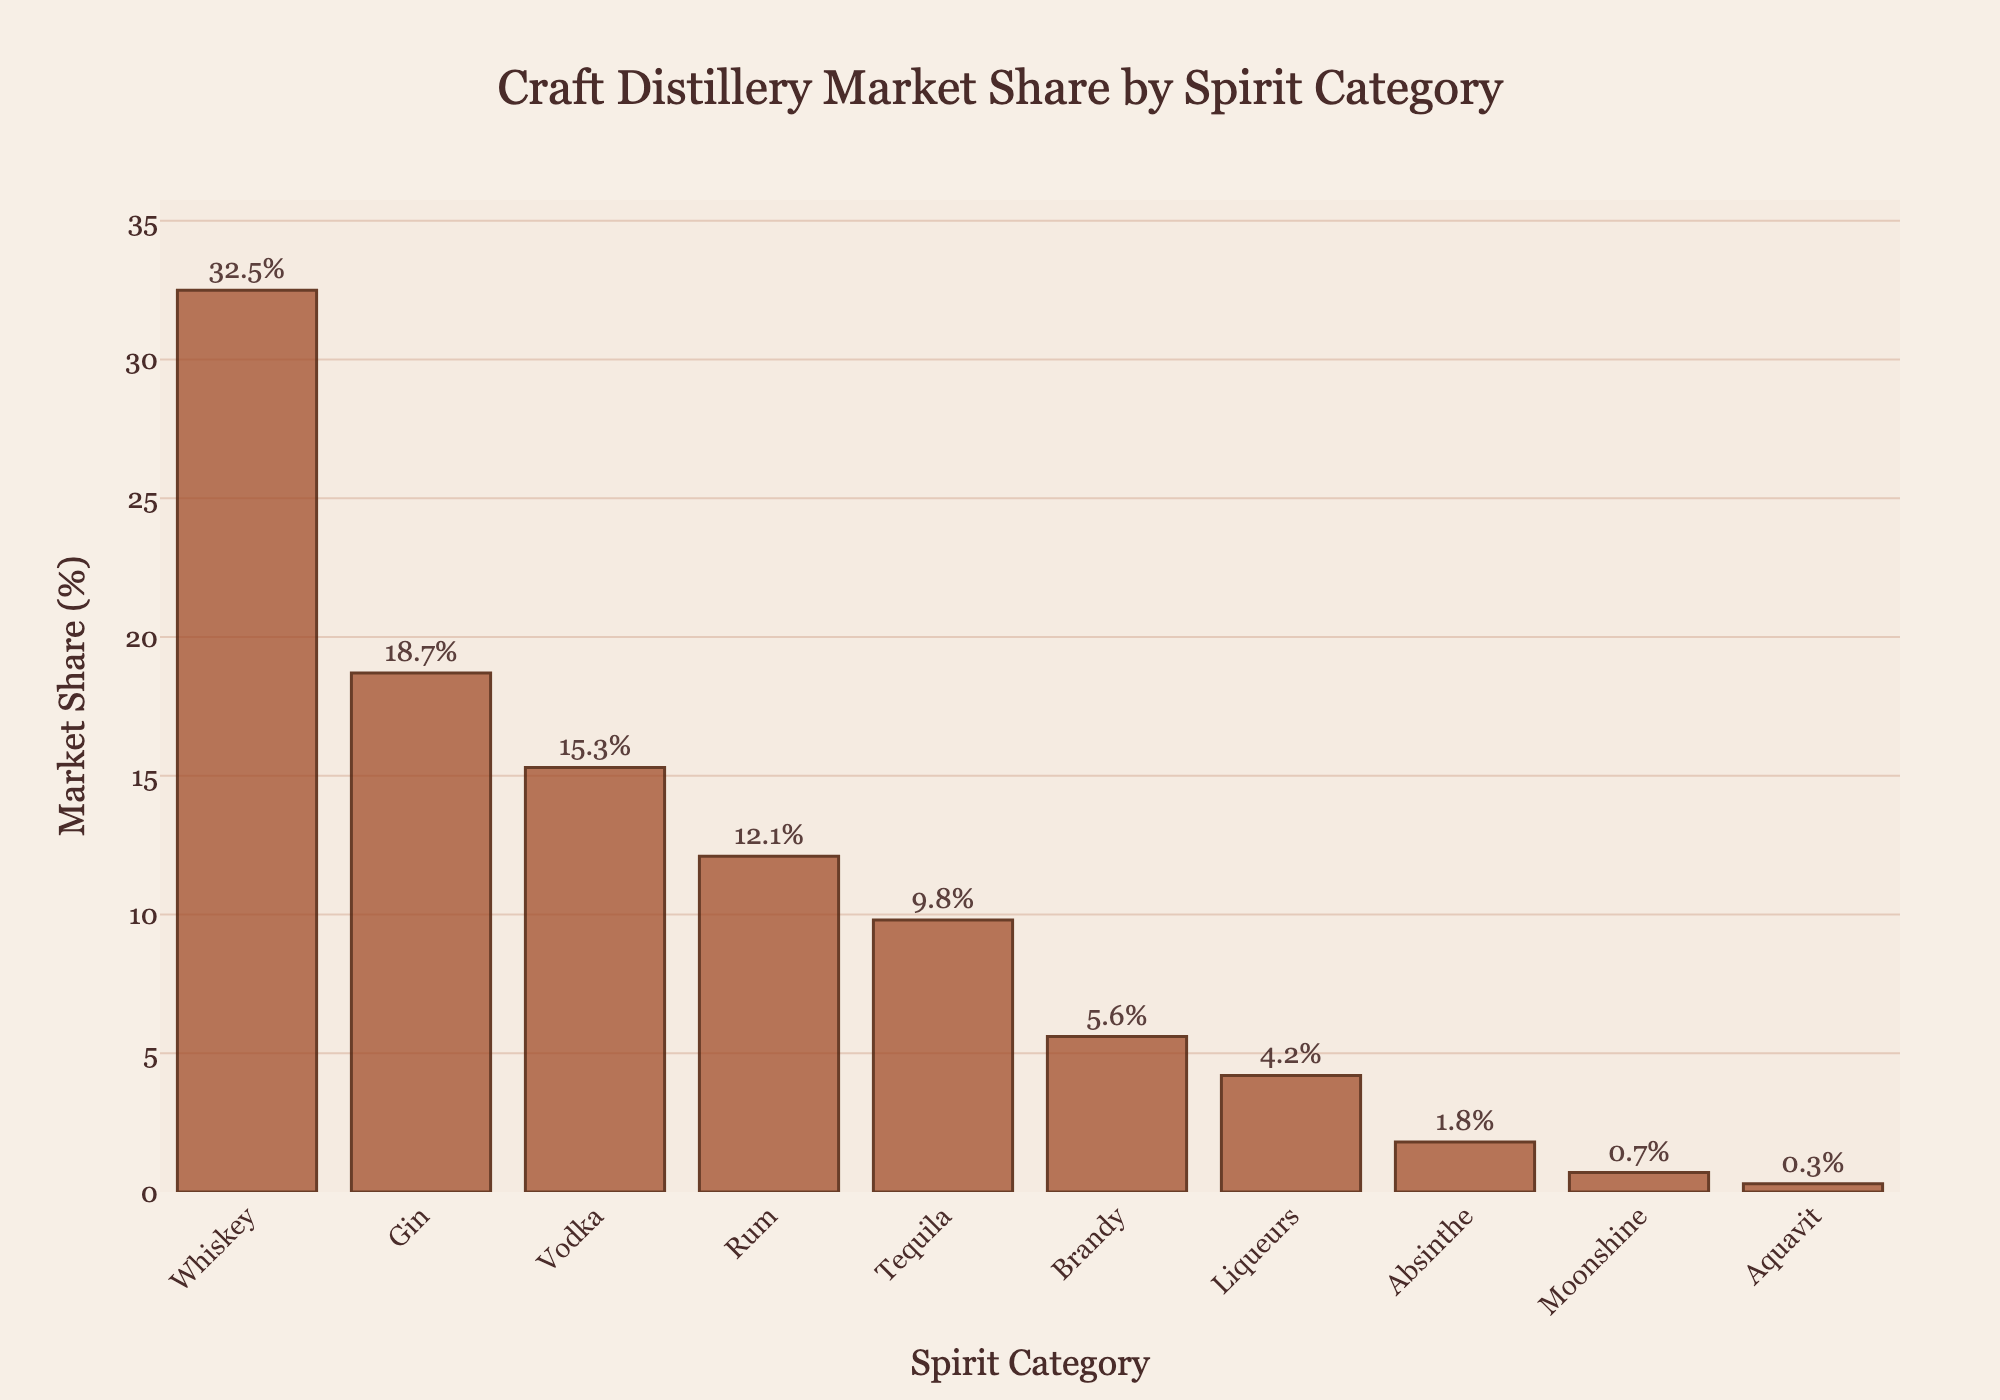Which spirit category has the highest market share? The bar representing Whiskey is the tallest in the chart, indicating it has the highest market share.
Answer: Whiskey Which spirit category comes second in market share after Whiskey? The second tallest bar in the chart represents Gin, indicating it has the second highest market share after Whiskey.
Answer: Gin What is the combined market share of Vodka and Rum? Vodka has a market share of 15.3% and Rum has 12.1%. Adding these together: 15.3 + 12.1 = 27.4%.
Answer: 27.4% How much higher is Whiskey's market share compared to Tequila? Whiskey's market share is 32.5% and Tequila's is 9.8%. The difference is 32.5 - 9.8 = 22.7%.
Answer: 22.7% Which is the least popular spirit category based on market share? The shortest bar in the chart represents Aquavit, indicating it has the smallest market share.
Answer: Aquavit What is the average market share of Whiskey, Gin, and Vodka? Summing the market shares of Whiskey (32.5%), Gin (18.7%), and Vodka (15.3%) gives 32.5 + 18.7 + 15.3 = 66.5%. The average is 66.5 / 3 = 22.17%.
Answer: 22.17% By what percentage does Rum's market share exceed Moonshine's? Rum has a market share of 12.1% and Moonshine has 0.7%. The percentage increase is ((12.1 - 0.7) / 0.7) * 100 = 1628.57%.
Answer: 1628.57% How many spirit categories have a market share less than 10%? By observing the bars, we see that Tequila, Brandy, Liqueurs, Absinthe, Moonshine, and Aquavit are all less than 10%. This makes 6 categories.
Answer: 6 What's the cumulative market share for categories with less than 5% share? Summing the market shares of Brandy (5.6%), Liqueurs (4.2%), Absinthe (1.8%), Moonshine (0.7%), and Aquavit (0.3%) gives 5.6 + 4.2 + 1.8 + 0.7 + 0.3 = 12.6%.
Answer: 12.6% Does Brandy's market share fall below the average market share of the top three spirit categories? The average market share of the top three categories (Whiskey, Gin, Vodka) is 22.17%. Brandy’s share is 5.6%, which is below this average.
Answer: Yes 